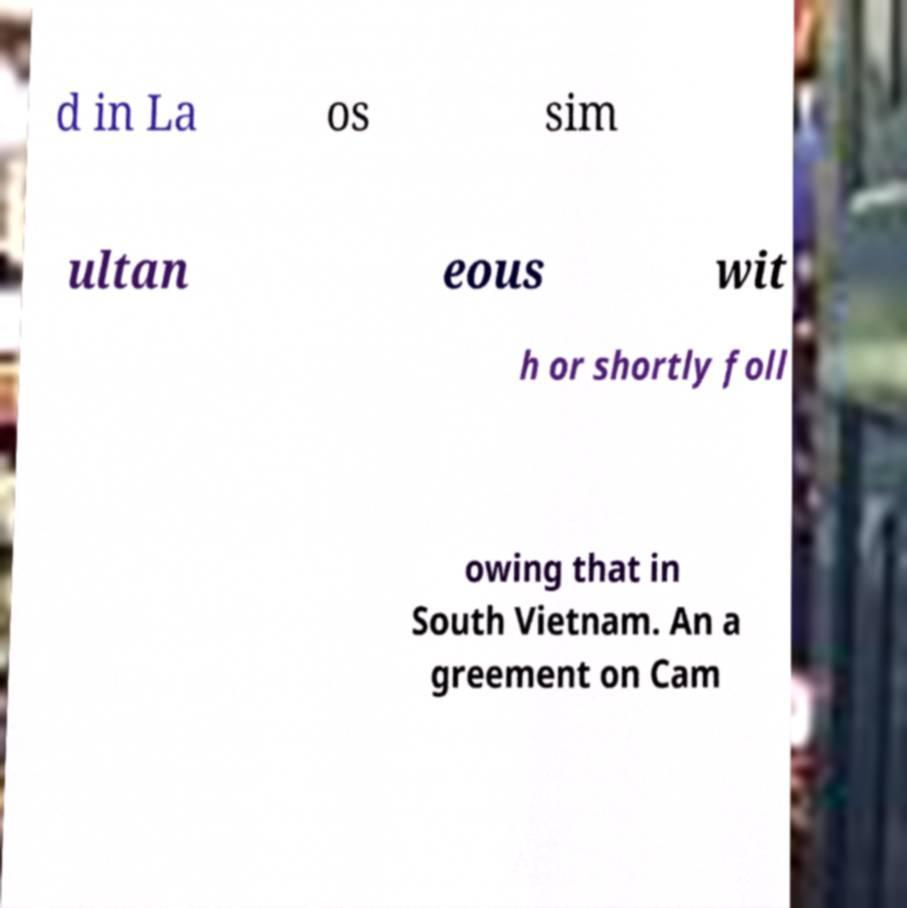What messages or text are displayed in this image? I need them in a readable, typed format. d in La os sim ultan eous wit h or shortly foll owing that in South Vietnam. An a greement on Cam 